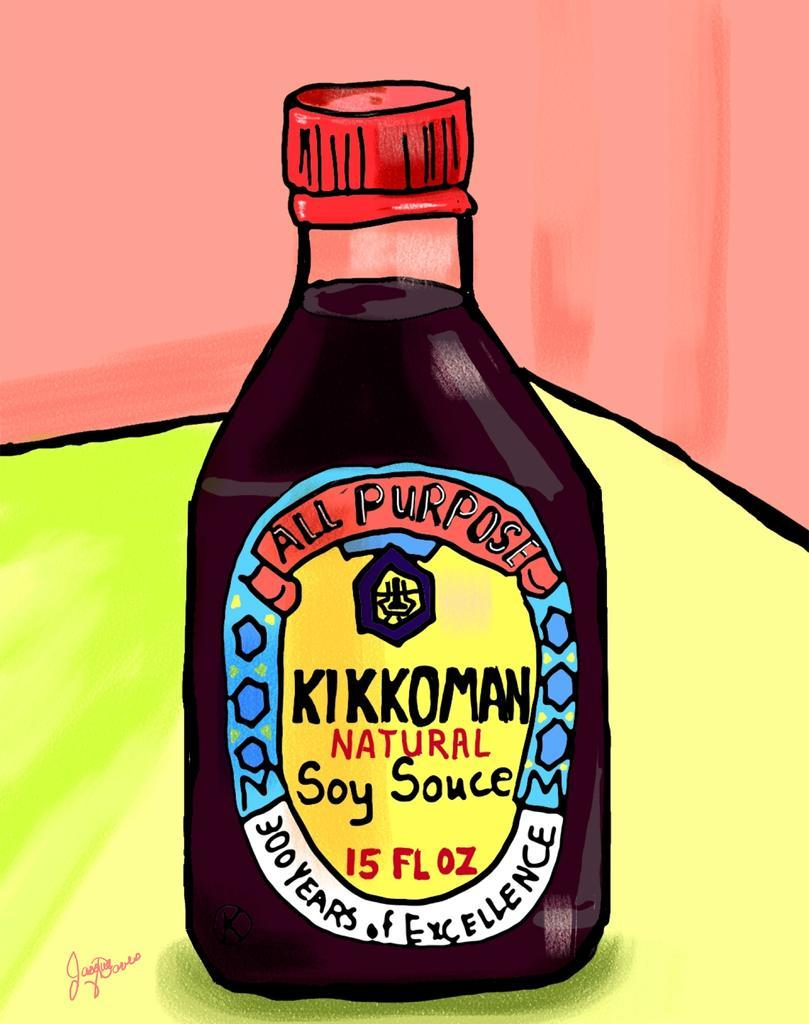Provide a one-sentence caption for the provided image. A cartoon drawing of kikkoman soy sauce on yellow table against a red wall.. 